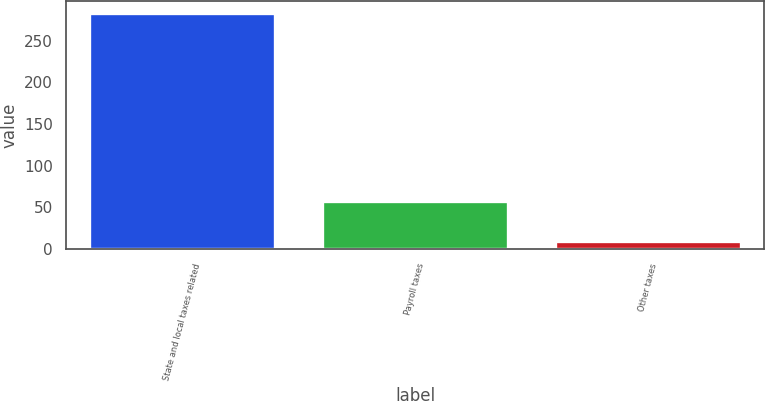Convert chart to OTSL. <chart><loc_0><loc_0><loc_500><loc_500><bar_chart><fcel>State and local taxes related<fcel>Payroll taxes<fcel>Other taxes<nl><fcel>283<fcel>57<fcel>9<nl></chart> 